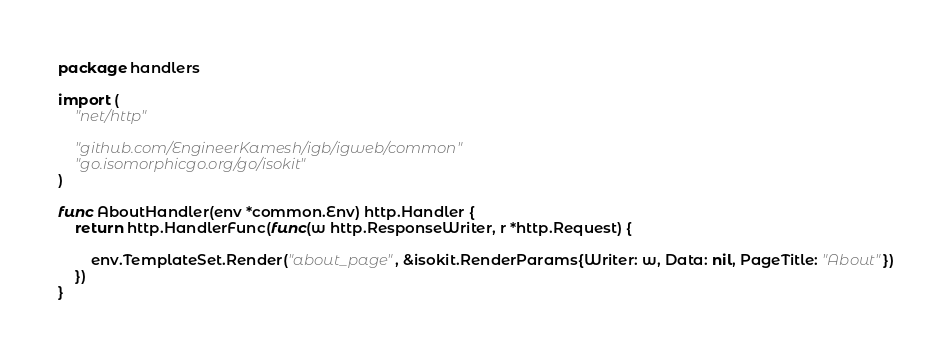Convert code to text. <code><loc_0><loc_0><loc_500><loc_500><_Go_>package handlers

import (
	"net/http"

	"github.com/EngineerKamesh/igb/igweb/common"
	"go.isomorphicgo.org/go/isokit"
)

func AboutHandler(env *common.Env) http.Handler {
	return http.HandlerFunc(func(w http.ResponseWriter, r *http.Request) {

		env.TemplateSet.Render("about_page", &isokit.RenderParams{Writer: w, Data: nil, PageTitle: "About"})
	})
}
</code> 